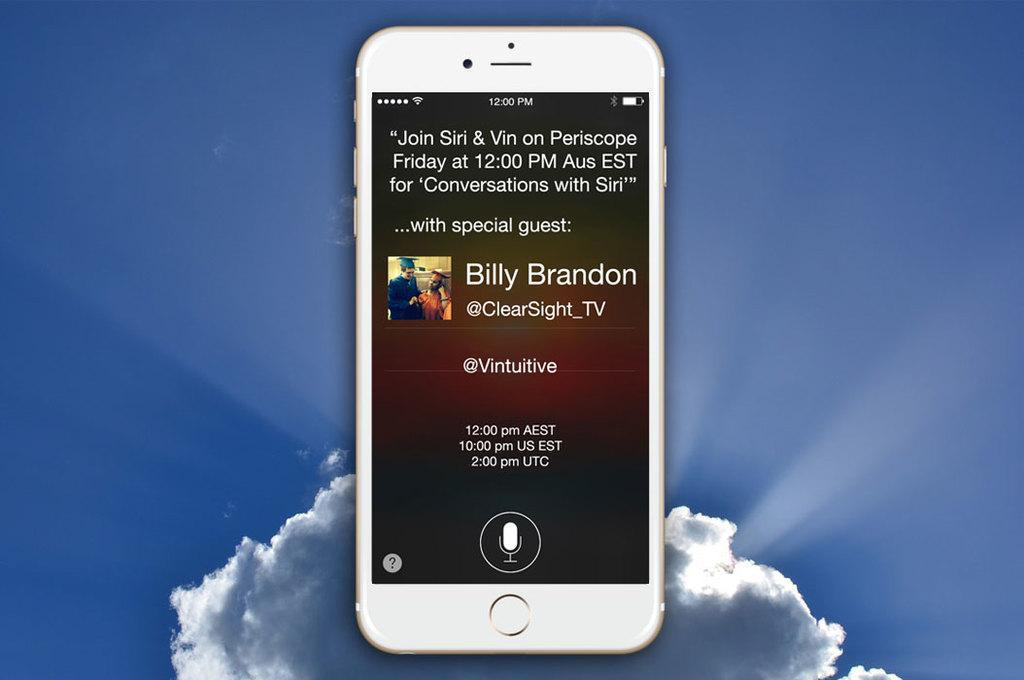Provide a one-sentence caption for the provided image. A white iPhone showing a message about a special guest named Billy Brandon. 